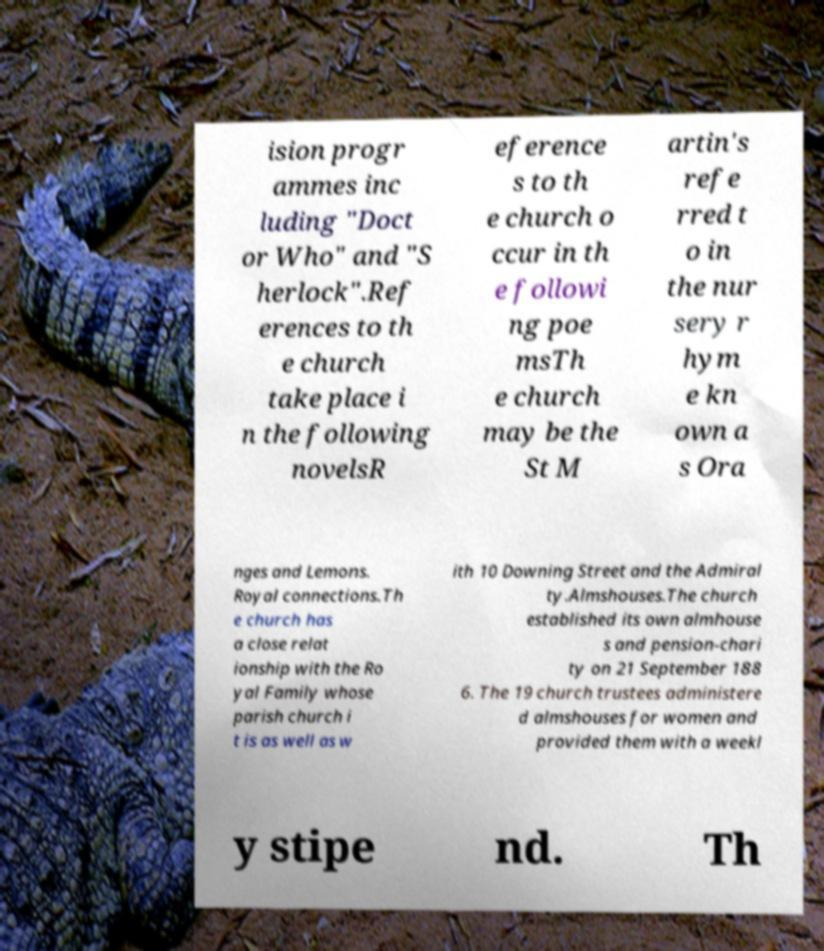I need the written content from this picture converted into text. Can you do that? ision progr ammes inc luding "Doct or Who" and "S herlock".Ref erences to th e church take place i n the following novelsR eference s to th e church o ccur in th e followi ng poe msTh e church may be the St M artin's refe rred t o in the nur sery r hym e kn own a s Ora nges and Lemons. Royal connections.Th e church has a close relat ionship with the Ro yal Family whose parish church i t is as well as w ith 10 Downing Street and the Admiral ty.Almshouses.The church established its own almhouse s and pension-chari ty on 21 September 188 6. The 19 church trustees administere d almshouses for women and provided them with a weekl y stipe nd. Th 